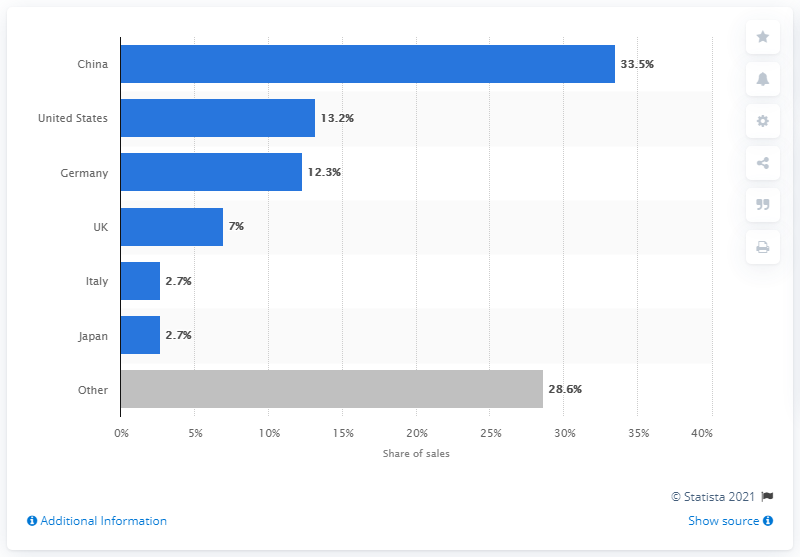Specify some key components in this picture. In 2020, China accounted for a significant portion of Rolls-Royce, BMW, and MINI sales, with a total of 33.5% of the company's global sales coming from this market. 